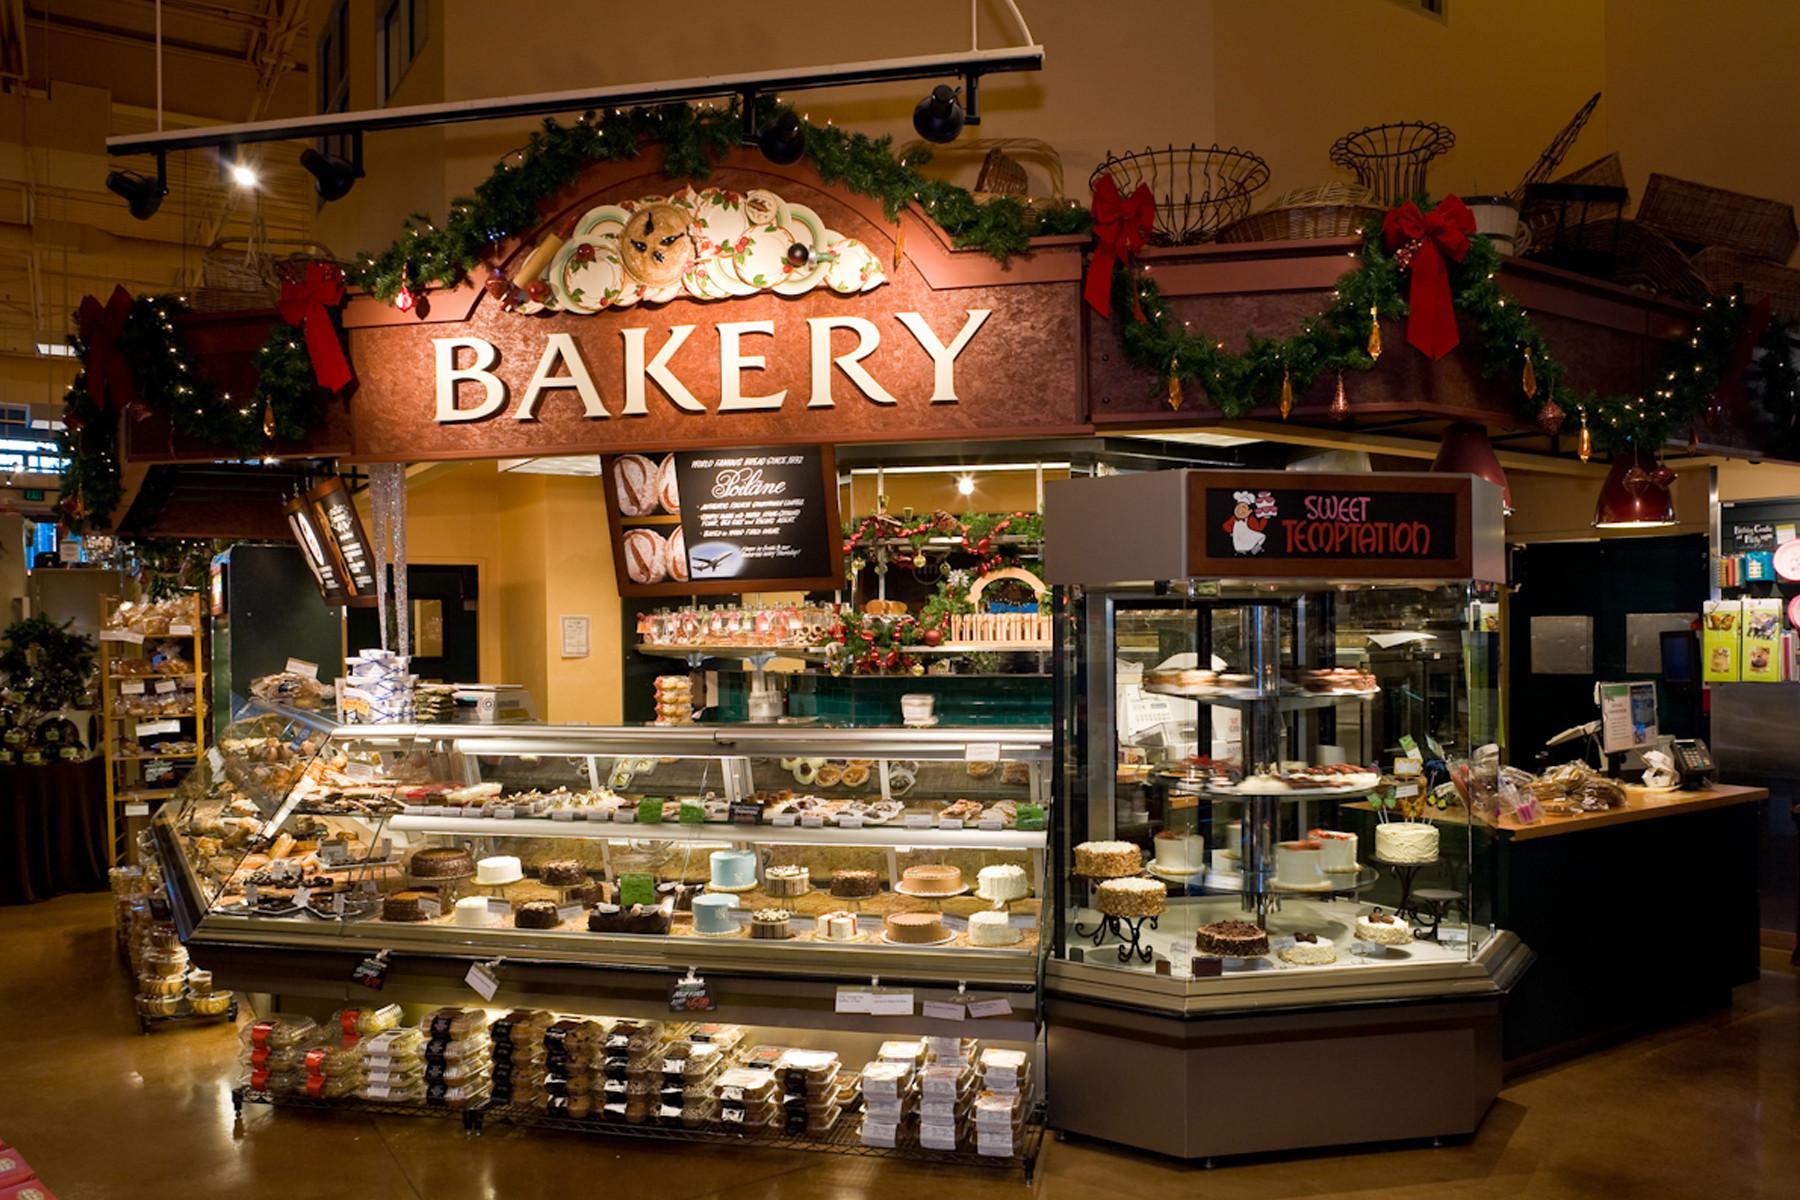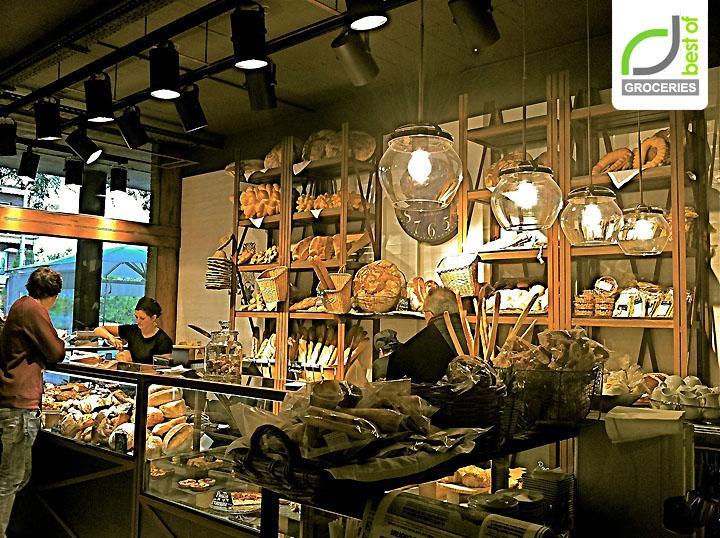The first image is the image on the left, the second image is the image on the right. Given the left and right images, does the statement "One display cabinet is a soft green color." hold true? Answer yes or no. No. 